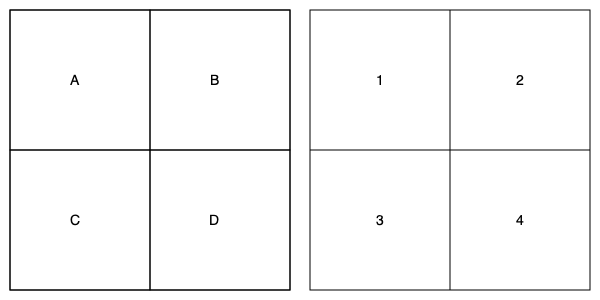Match the 2D floor plan (left) with its corresponding 3D room rendering (right). Which 3D room rendering corresponds to the floor plan labeled 'B'? To match the 2D floor plan with its corresponding 3D room rendering, we need to analyze the spatial relationships and proportions in both representations:

1. Examine the 2D floor plan:
   - Plan 'B' is located in the top-right quadrant of the 2D layout.
   - It shares walls with plans 'A' (left) and 'D' (below).

2. Analyze the 3D renderings:
   - Rendering 1: Top-left room, shares walls with 2 and 3.
   - Rendering 2: Top-right room, shares walls with 1 and 4.
   - Rendering 3: Bottom-left room, shares walls with 1 and 4.
   - Rendering 4: Bottom-right room, shares walls with 2 and 3.

3. Compare the spatial relationships:
   - Plan 'B' is in the top-right, matching the position of rendering 2.
   - Plan 'B' shares walls with 'A' (left) and 'D' (below), which corresponds to rendering 2 sharing walls with 1 (left) and 4 (below).

4. Confirm the match:
   - The spatial relationships and relative positions of plan 'B' align perfectly with rendering 2.

Therefore, the 3D room rendering that corresponds to the floor plan labeled 'B' is rendering 2.
Answer: 2 